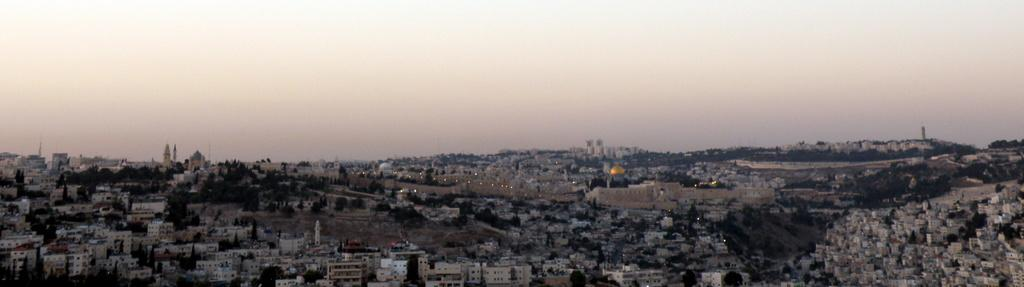What type of natural elements can be seen in the image? There are trees in the image. What type of man-made structures are present in the image? There are buildings in the image. What is visible in the background of the image? The sky is visible in the background of the image. What type of jam is being spread on the seat in the image? There is no seat or jam present in the image; it features trees and buildings with the sky visible in the background. 